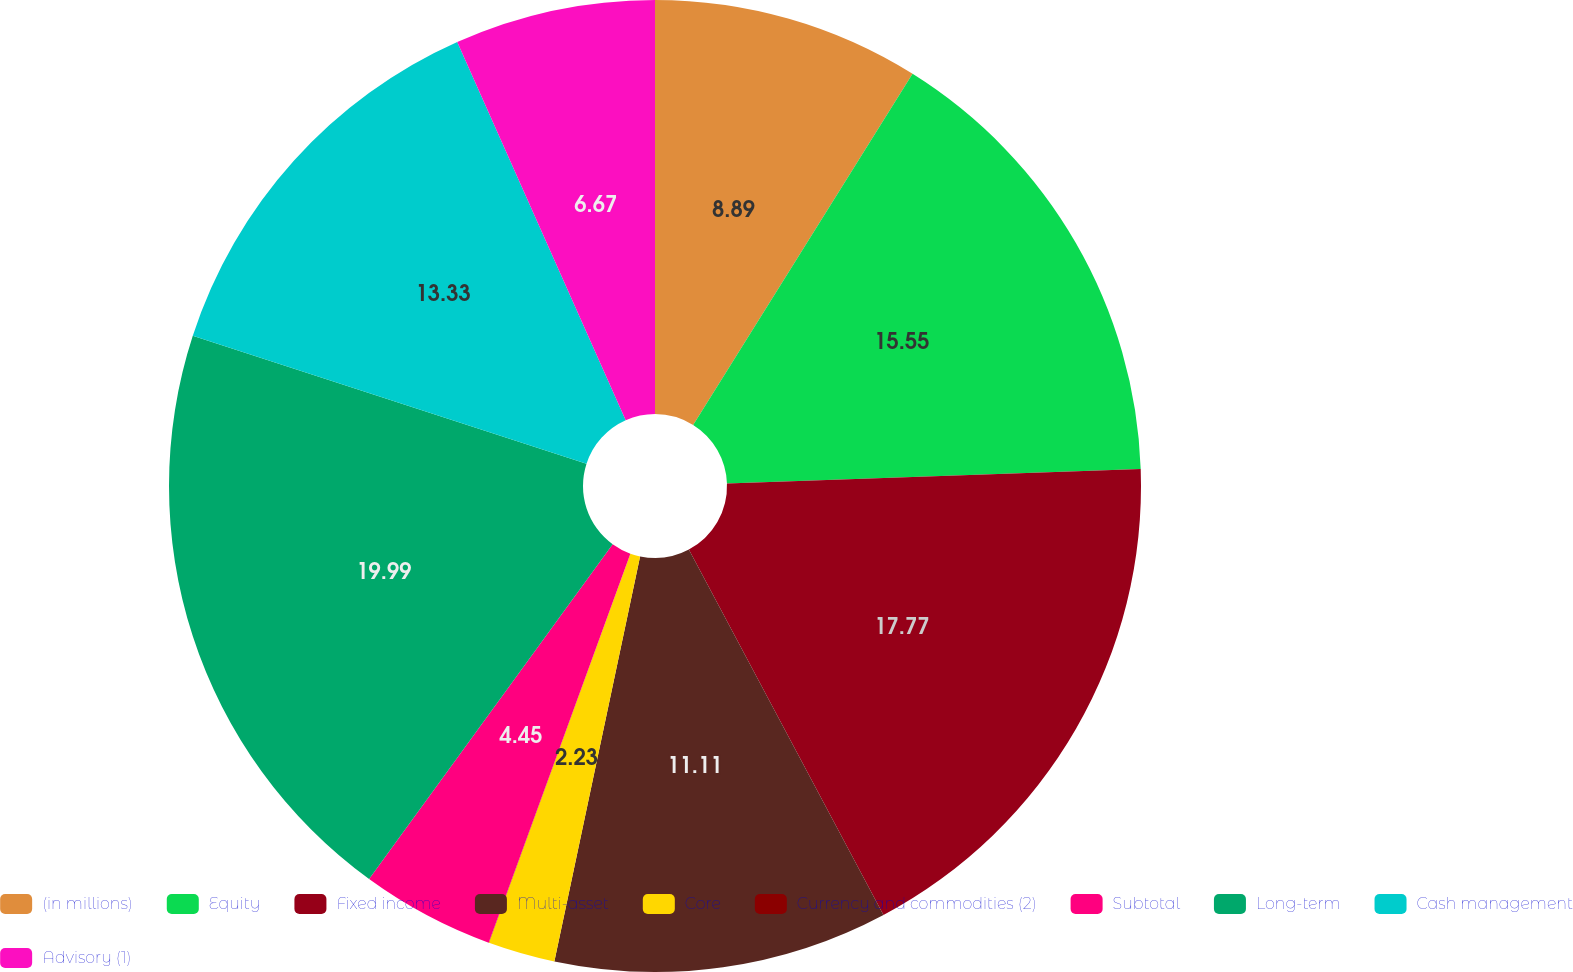Convert chart. <chart><loc_0><loc_0><loc_500><loc_500><pie_chart><fcel>(in millions)<fcel>Equity<fcel>Fixed income<fcel>Multi-asset<fcel>Core<fcel>Currency and commodities (2)<fcel>Subtotal<fcel>Long-term<fcel>Cash management<fcel>Advisory (1)<nl><fcel>8.89%<fcel>15.55%<fcel>17.77%<fcel>11.11%<fcel>2.23%<fcel>0.01%<fcel>4.45%<fcel>19.99%<fcel>13.33%<fcel>6.67%<nl></chart> 